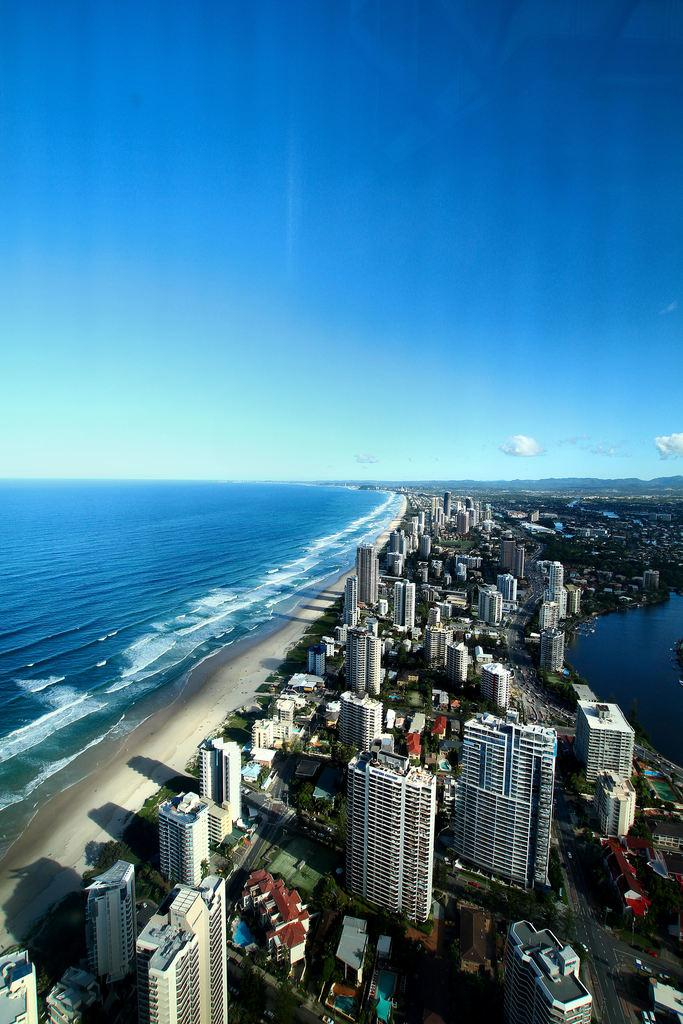What type of structures can be seen in the image? There are buildings in the image. What other natural elements are present in the image? There are trees in the image. Can you describe any objects visible in the image? There are objects in the image, but their specific nature is not mentioned in the facts. What can be seen in the distance in the image? There is water, mountains, and the sky visible in the background of the image. What is the condition of the sky in the image? Clouds are present in the sky in the image. How does the wren interact with the chair in the image? There is no chair or wren present in the image. What type of friction is created by the objects in the image? The facts do not provide information about the objects or their interactions, so it is impossible to determine the type of friction present. 